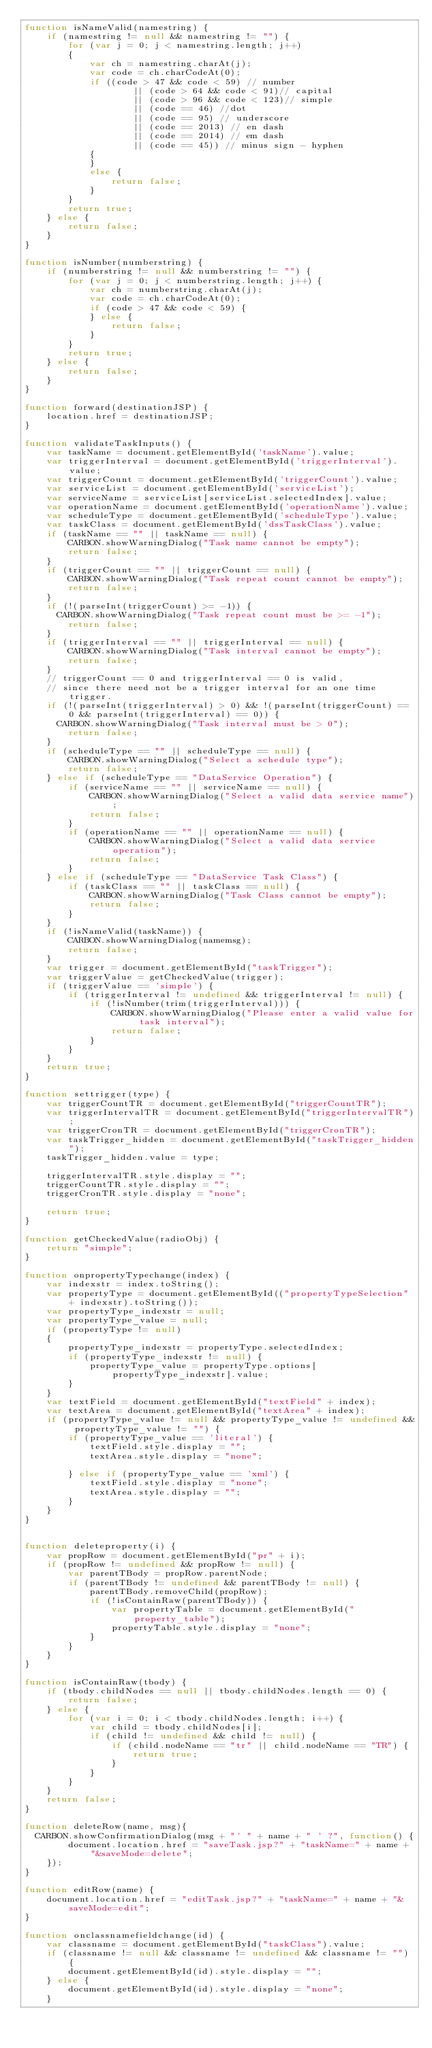Convert code to text. <code><loc_0><loc_0><loc_500><loc_500><_JavaScript_>function isNameValid(namestring) {
    if (namestring != null && namestring != "") {
        for (var j = 0; j < namestring.length; j++)
        {
            var ch = namestring.charAt(j);
            var code = ch.charCodeAt(0);
            if ((code > 47 && code < 59) // number
                    || (code > 64 && code < 91)// capital 
                    || (code > 96 && code < 123)// simple
                    || (code == 46) //dot
                    || (code == 95) // underscore
                    || (code == 2013) // en dash
                    || (code == 2014) // em dash
                    || (code == 45)) // minus sign - hyphen
            {
            }
            else {
                return false;
            }
        }
        return true;
    } else {
        return false;
    }
}

function isNumber(numberstring) {
    if (numberstring != null && numberstring != "") {
        for (var j = 0; j < numberstring.length; j++) {
            var ch = numberstring.charAt(j);
            var code = ch.charCodeAt(0);
            if (code > 47 && code < 59) {
            } else {
                return false;
            }
        }
        return true;
    } else {
        return false;
    }
}

function forward(destinationJSP) {
    location.href = destinationJSP;
}

function validateTaskInputs() {
    var taskName = document.getElementById('taskName').value;
    var triggerInterval = document.getElementById('triggerInterval').value;
    var triggerCount = document.getElementById('triggerCount').value;
    var serviceList = document.getElementById('serviceList');
    var serviceName = serviceList[serviceList.selectedIndex].value;
    var operationName = document.getElementById('operationName').value;
    var scheduleType = document.getElementById('scheduleType').value;
    var taskClass = document.getElementById('dssTaskClass').value;
    if (taskName == "" || taskName == null) {
        CARBON.showWarningDialog("Task name cannot be empty");
        return false;
    }
    if (triggerCount == "" || triggerCount == null) {
        CARBON.showWarningDialog("Task repeat count cannot be empty");
        return false;
    }
    if (!(parseInt(triggerCount) >= -1)) {
    	CARBON.showWarningDialog("Task repeat count must be >= -1");
        return false;
    }
    if (triggerInterval == "" || triggerInterval == null) {
        CARBON.showWarningDialog("Task interval cannot be empty");
        return false;
    }
    // triggerCount == 0 and triggerInterval == 0 is valid, 
    // since there need not be a trigger interval for an one time trigger.
    if (!(parseInt(triggerInterval) > 0) && !(parseInt(triggerCount) == 0 && parseInt(triggerInterval) == 0)) {
    	CARBON.showWarningDialog("Task interval must be > 0");
        return false;
    }
    if (scheduleType == "" || scheduleType == null) {
        CARBON.showWarningDialog("Select a schedule type");
        return false;
    } else if (scheduleType == "DataService Operation") {
        if (serviceName == "" || serviceName == null) {
            CARBON.showWarningDialog("Select a valid data service name");
            return false;
        }
        if (operationName == "" || operationName == null) {
            CARBON.showWarningDialog("Select a valid data service operation");
            return false;
        }
    } else if (scheduleType == "DataService Task Class") {
        if (taskClass == "" || taskClass == null) {
            CARBON.showWarningDialog("Task Class cannot be empty");
            return false;
        }
    }
    if (!isNameValid(taskName)) {
        CARBON.showWarningDialog(namemsg);
        return false;
    }
    var trigger = document.getElementById("taskTrigger");
    var triggerValue = getCheckedValue(trigger);
    if (triggerValue == 'simple') {
        if (triggerInterval != undefined && triggerInterval != null) {
            if (!isNumber(trim(triggerInterval))) {
                CARBON.showWarningDialog("Please enter a valid value for task interval");
                return false;
            }
        }
    }
    return true;
}

function settrigger(type) {
    var triggerCountTR = document.getElementById("triggerCountTR");
    var triggerIntervalTR = document.getElementById("triggerIntervalTR");
    var triggerCronTR = document.getElementById("triggerCronTR");
    var taskTrigger_hidden = document.getElementById("taskTrigger_hidden");
    taskTrigger_hidden.value = type;

    triggerIntervalTR.style.display = "";
    triggerCountTR.style.display = "";
    triggerCronTR.style.display = "none";

    return true;
}

function getCheckedValue(radioObj) {
    return "simple";
}

function onpropertyTypechange(index) {
    var indexstr = index.toString();
    var propertyType = document.getElementById(("propertyTypeSelection" + indexstr).toString());
    var propertyType_indexstr = null;
    var propertyType_value = null;
    if (propertyType != null)
    {
        propertyType_indexstr = propertyType.selectedIndex;
        if (propertyType_indexstr != null) {
            propertyType_value = propertyType.options[propertyType_indexstr].value;
        }
    }
    var textField = document.getElementById("textField" + index);
    var textArea = document.getElementById("textArea" + index);
    if (propertyType_value != null && propertyType_value != undefined && propertyType_value != "") {
        if (propertyType_value == 'literal') {
            textField.style.display = "";
            textArea.style.display = "none";

        } else if (propertyType_value == 'xml') {
            textField.style.display = "none";
            textArea.style.display = "";
        }
    }
}


function deleteproperty(i) {
    var propRow = document.getElementById("pr" + i);
    if (propRow != undefined && propRow != null) {
        var parentTBody = propRow.parentNode;
        if (parentTBody != undefined && parentTBody != null) {
            parentTBody.removeChild(propRow);
            if (!isContainRaw(parentTBody)) {
                var propertyTable = document.getElementById("property_table");
                propertyTable.style.display = "none";
            }
        }
    }
}

function isContainRaw(tbody) {
    if (tbody.childNodes == null || tbody.childNodes.length == 0) {
        return false;
    } else {
        for (var i = 0; i < tbody.childNodes.length; i++) {
            var child = tbody.childNodes[i];
            if (child != undefined && child != null) {
                if (child.nodeName == "tr" || child.nodeName == "TR") {
                    return true;
                }
            }
        }
    }
    return false;
}

function deleteRow(name, msg){
	CARBON.showConfirmationDialog(msg + "' " + name + " ' ?", function() {
        document.location.href = "saveTask.jsp?" + "taskName=" + name + "&saveMode=delete";
    });
}

function editRow(name) {
    document.location.href = "editTask.jsp?" + "taskName=" + name + "&saveMode=edit";
}

function onclassnamefieldchange(id) {
    var classname = document.getElementById("taskClass").value;
    if (classname != null && classname != undefined && classname != "") {
        document.getElementById(id).style.display = "";
    } else {
        document.getElementById(id).style.display = "none";
    }</code> 